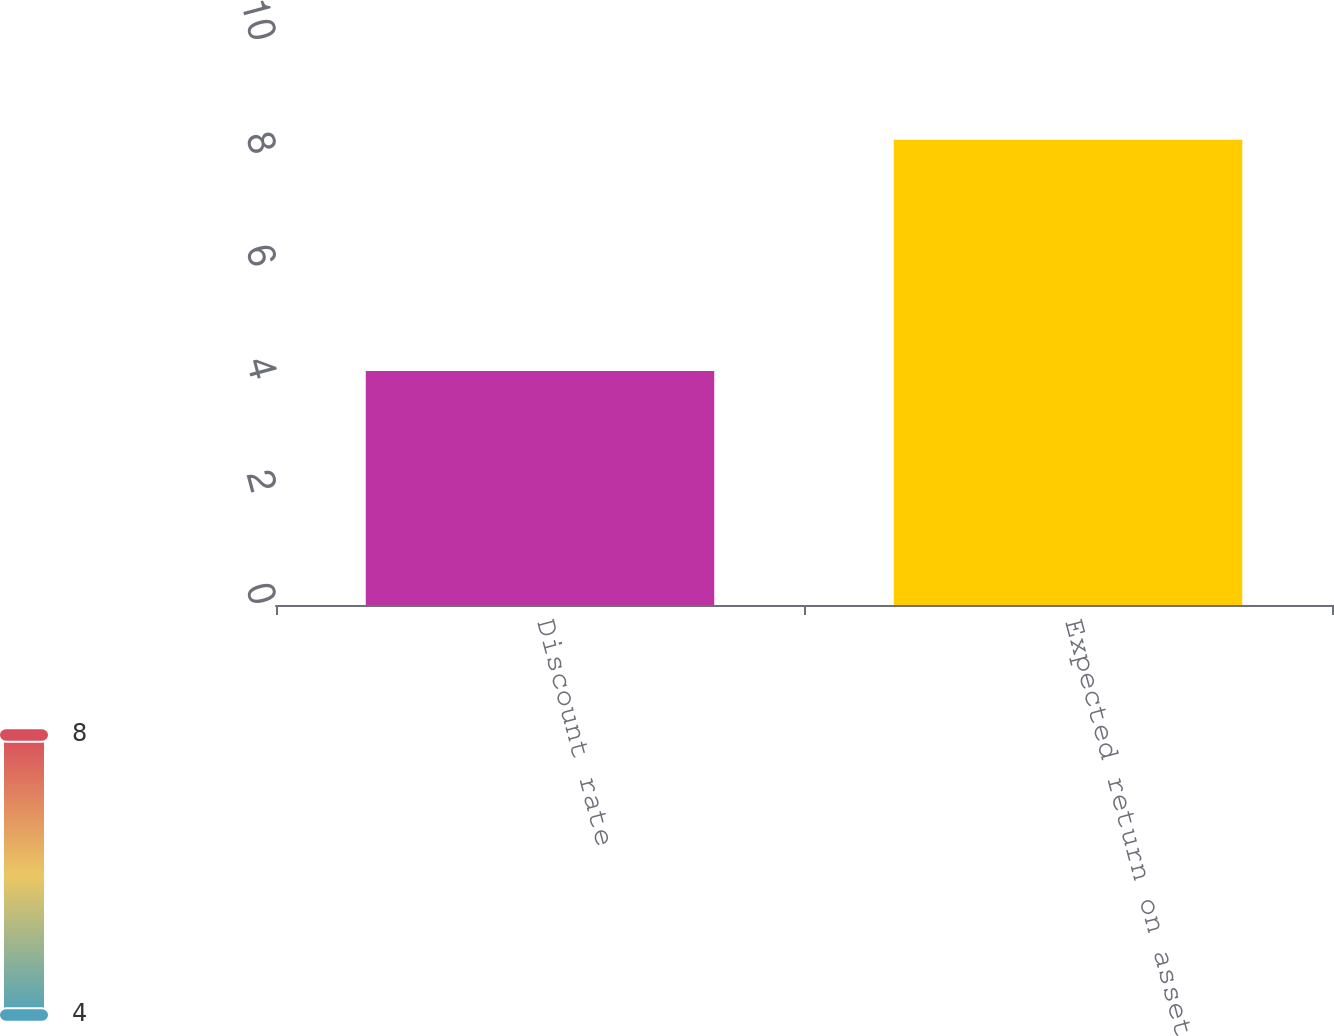<chart> <loc_0><loc_0><loc_500><loc_500><bar_chart><fcel>Discount rate<fcel>Expected return on assets<nl><fcel>4.15<fcel>8.25<nl></chart> 